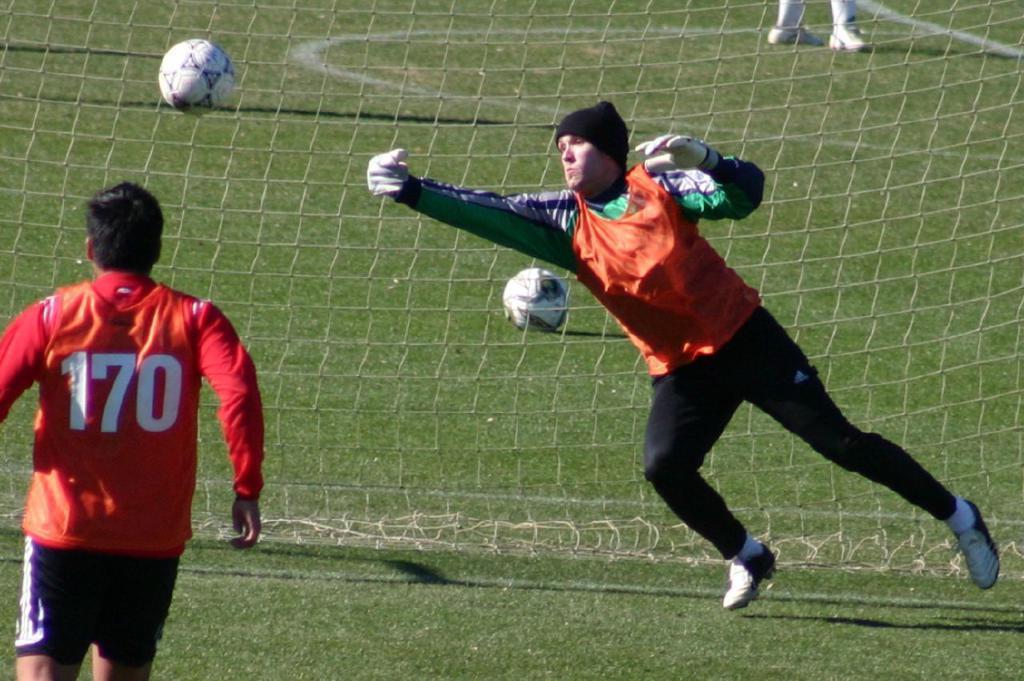Describe this image in one or two sentences. In this image we can see two persons wearing different color dress playing football and at the background of the image there are two balls, net and a person legs. 